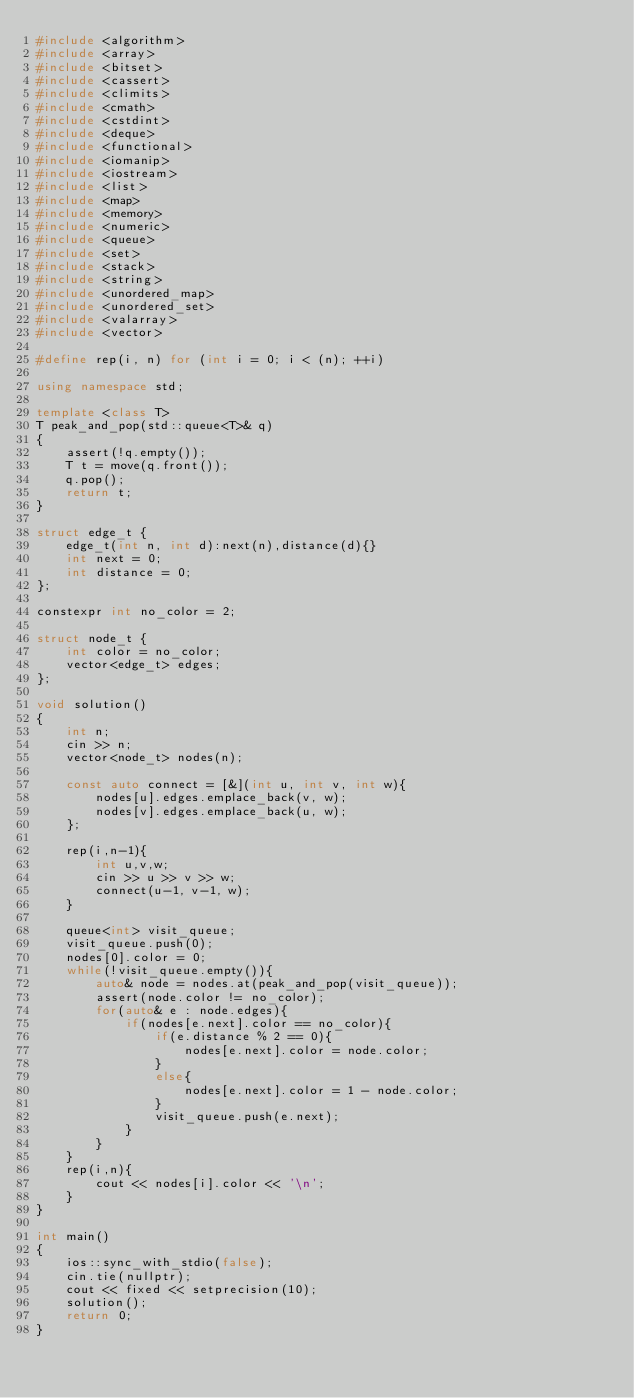Convert code to text. <code><loc_0><loc_0><loc_500><loc_500><_C++_>#include <algorithm>
#include <array>
#include <bitset>
#include <cassert>
#include <climits>
#include <cmath>
#include <cstdint>
#include <deque>
#include <functional>
#include <iomanip>
#include <iostream>
#include <list>
#include <map>
#include <memory>
#include <numeric>
#include <queue>
#include <set>
#include <stack>
#include <string>
#include <unordered_map>
#include <unordered_set>
#include <valarray>
#include <vector>

#define rep(i, n) for (int i = 0; i < (n); ++i)

using namespace std;

template <class T>
T peak_and_pop(std::queue<T>& q)
{
    assert(!q.empty());
    T t = move(q.front());
    q.pop();
    return t;
}

struct edge_t {
    edge_t(int n, int d):next(n),distance(d){}
    int next = 0;
    int distance = 0;
};

constexpr int no_color = 2;

struct node_t {
    int color = no_color;
    vector<edge_t> edges;
};

void solution()
{
    int n;
    cin >> n;
    vector<node_t> nodes(n);

    const auto connect = [&](int u, int v, int w){
        nodes[u].edges.emplace_back(v, w);
        nodes[v].edges.emplace_back(u, w);
    };

    rep(i,n-1){
        int u,v,w;
        cin >> u >> v >> w;
        connect(u-1, v-1, w);
    }

    queue<int> visit_queue;
    visit_queue.push(0);
    nodes[0].color = 0;
    while(!visit_queue.empty()){
        auto& node = nodes.at(peak_and_pop(visit_queue));
        assert(node.color != no_color);
        for(auto& e : node.edges){
            if(nodes[e.next].color == no_color){
                if(e.distance % 2 == 0){
                    nodes[e.next].color = node.color;
                }
                else{
                    nodes[e.next].color = 1 - node.color;
                }
                visit_queue.push(e.next);
            }
        }
    }
    rep(i,n){
        cout << nodes[i].color << '\n';
    }
}

int main()
{
    ios::sync_with_stdio(false);
    cin.tie(nullptr);
    cout << fixed << setprecision(10);
    solution();
    return 0;
}
</code> 